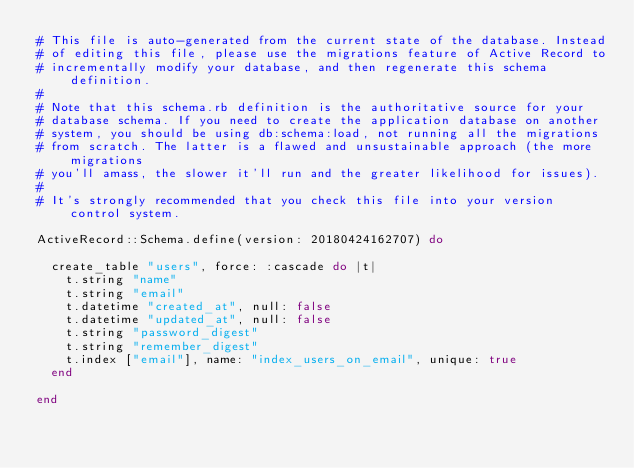Convert code to text. <code><loc_0><loc_0><loc_500><loc_500><_Ruby_># This file is auto-generated from the current state of the database. Instead
# of editing this file, please use the migrations feature of Active Record to
# incrementally modify your database, and then regenerate this schema definition.
#
# Note that this schema.rb definition is the authoritative source for your
# database schema. If you need to create the application database on another
# system, you should be using db:schema:load, not running all the migrations
# from scratch. The latter is a flawed and unsustainable approach (the more migrations
# you'll amass, the slower it'll run and the greater likelihood for issues).
#
# It's strongly recommended that you check this file into your version control system.

ActiveRecord::Schema.define(version: 20180424162707) do

  create_table "users", force: :cascade do |t|
    t.string "name"
    t.string "email"
    t.datetime "created_at", null: false
    t.datetime "updated_at", null: false
    t.string "password_digest"
    t.string "remember_digest"
    t.index ["email"], name: "index_users_on_email", unique: true
  end

end
</code> 